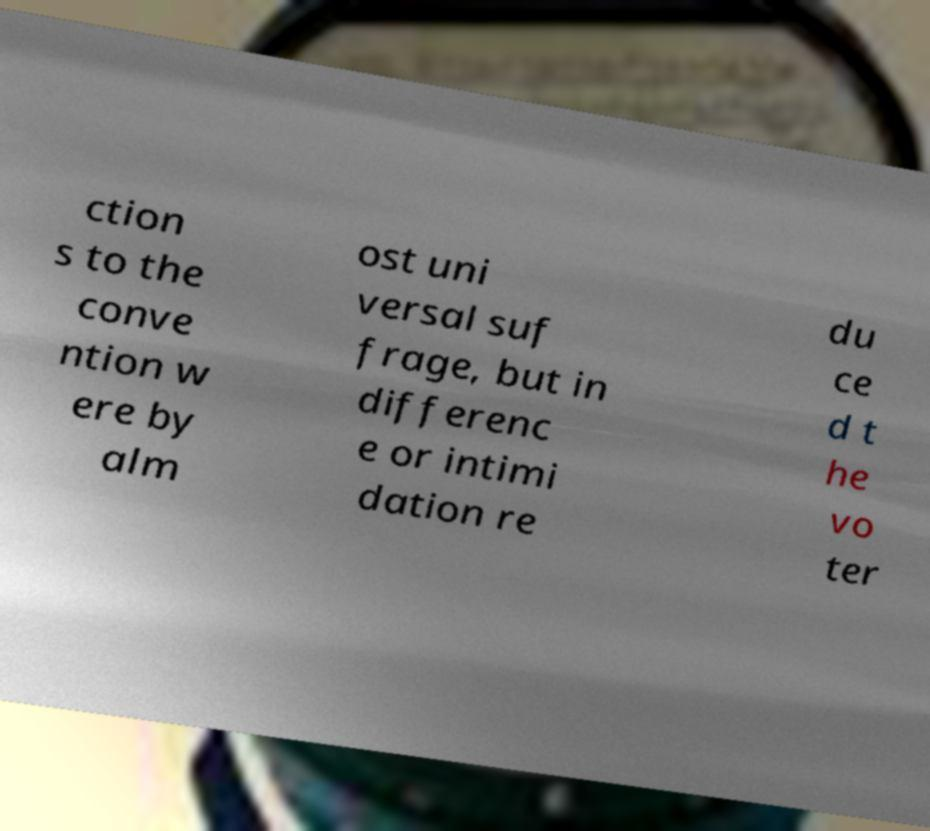Can you read and provide the text displayed in the image?This photo seems to have some interesting text. Can you extract and type it out for me? ction s to the conve ntion w ere by alm ost uni versal suf frage, but in differenc e or intimi dation re du ce d t he vo ter 